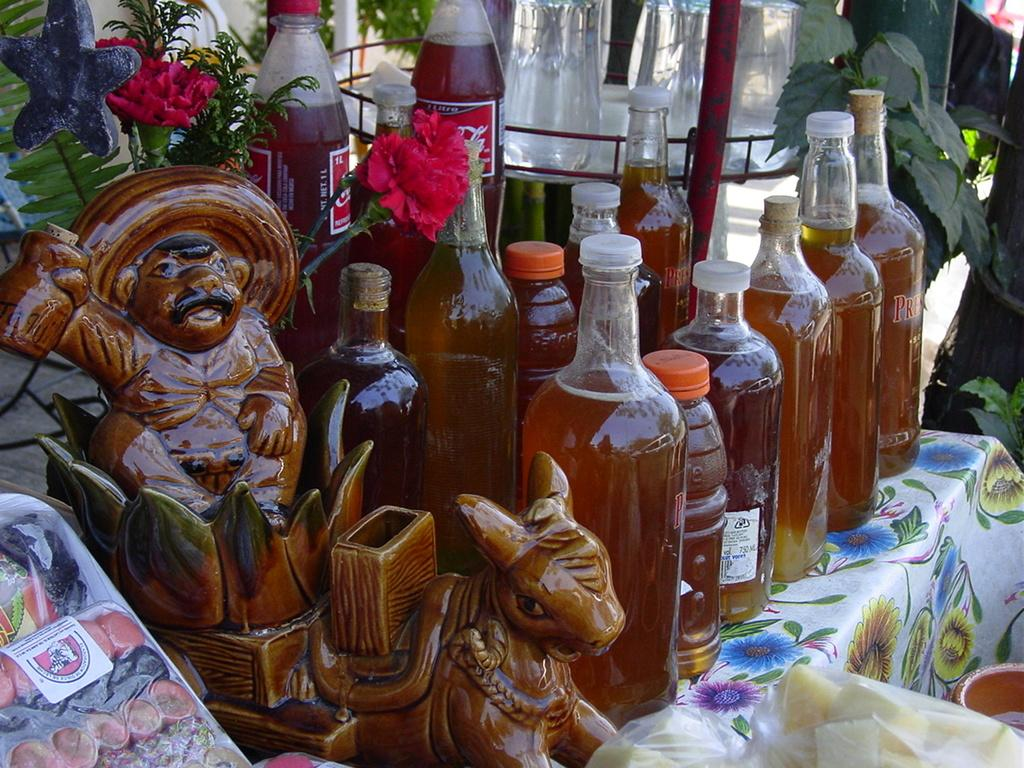What objects are on the table in the image? There are glass bottles on a table in the image. What can be seen on the left side of the image? There is a sculpture and a food item on the left side of the image. What type of vegetation isation is visible in the image? There are flowers and plants visible at the back and on the right side of the image. What type of clouds can be seen in the image? There are no clouds visible in the image. What role does the cast play in the image? There is no cast present in the image. 